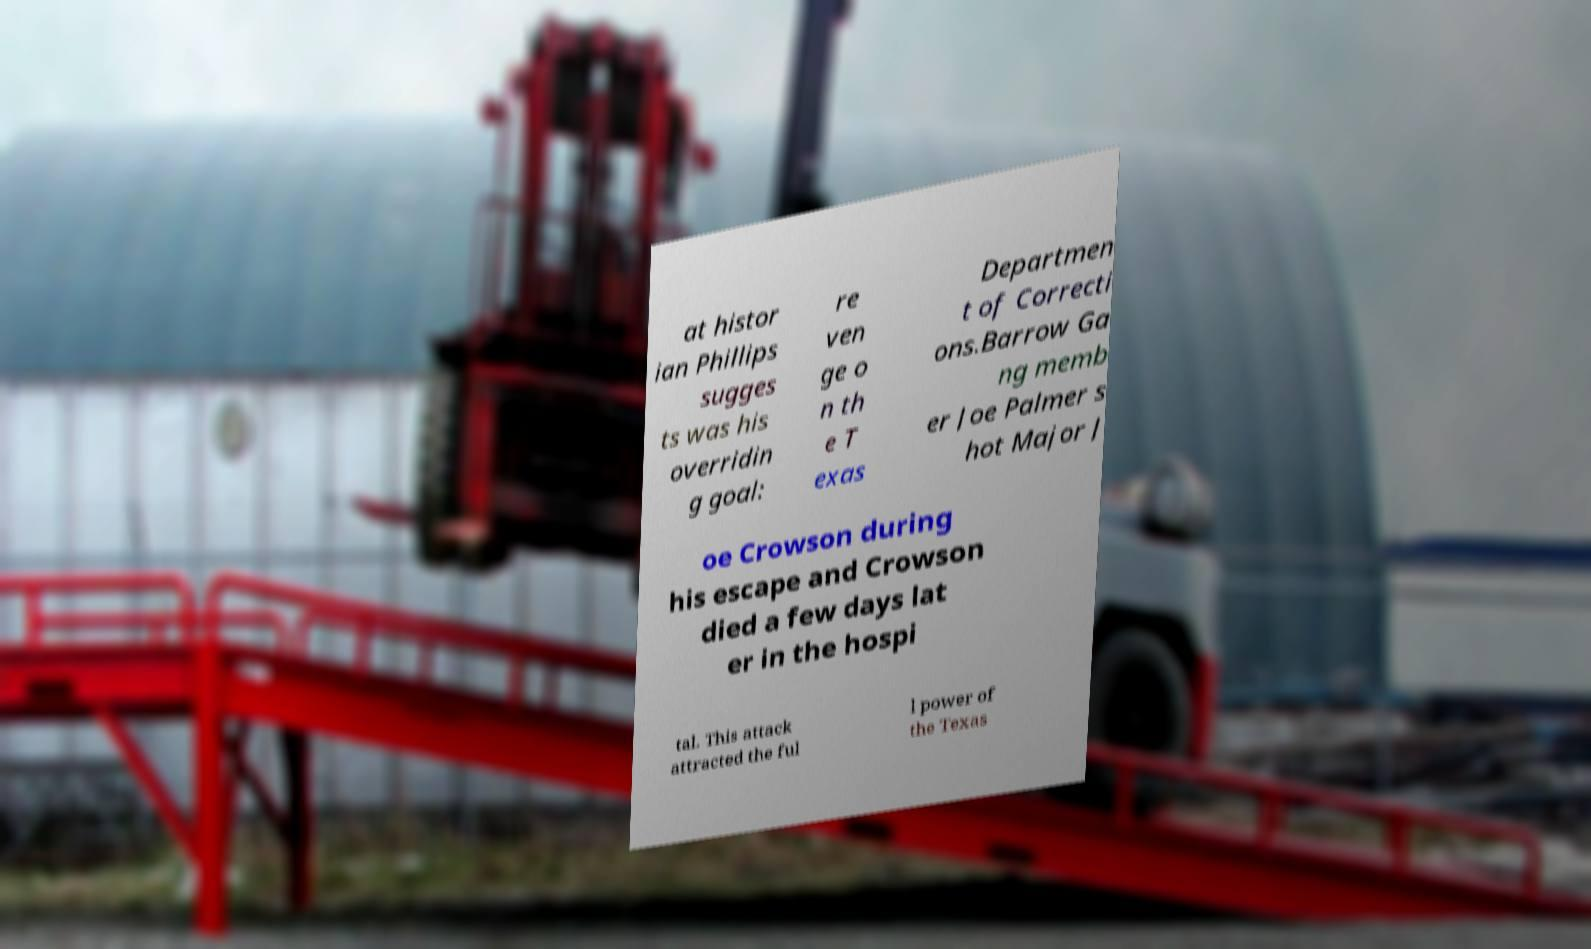I need the written content from this picture converted into text. Can you do that? at histor ian Phillips sugges ts was his overridin g goal: re ven ge o n th e T exas Departmen t of Correcti ons.Barrow Ga ng memb er Joe Palmer s hot Major J oe Crowson during his escape and Crowson died a few days lat er in the hospi tal. This attack attracted the ful l power of the Texas 